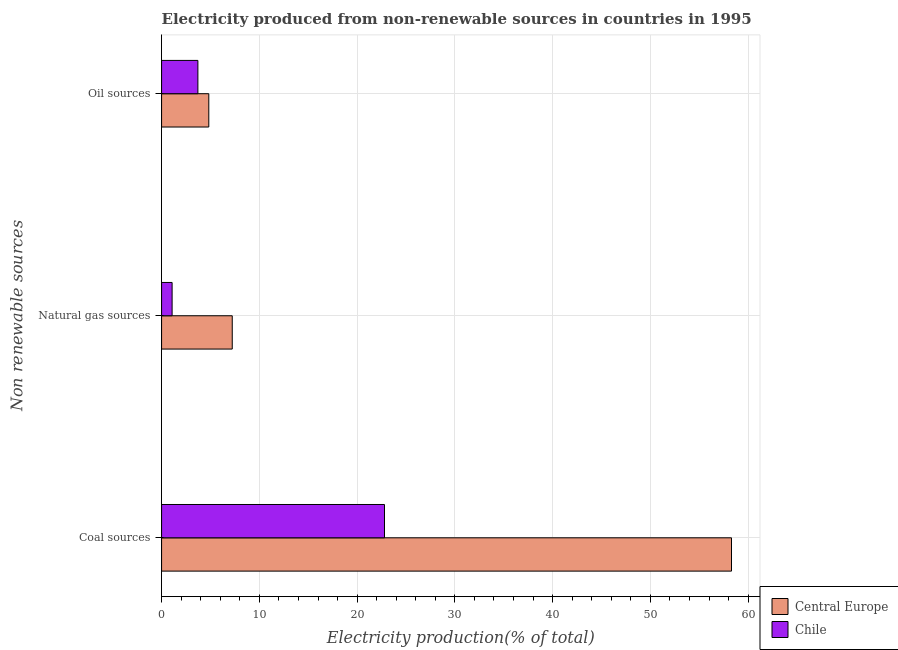Are the number of bars per tick equal to the number of legend labels?
Keep it short and to the point. Yes. How many bars are there on the 2nd tick from the top?
Give a very brief answer. 2. What is the label of the 3rd group of bars from the top?
Provide a short and direct response. Coal sources. What is the percentage of electricity produced by oil sources in Chile?
Make the answer very short. 3.71. Across all countries, what is the maximum percentage of electricity produced by oil sources?
Your answer should be compact. 4.83. Across all countries, what is the minimum percentage of electricity produced by oil sources?
Ensure brevity in your answer.  3.71. In which country was the percentage of electricity produced by oil sources maximum?
Provide a short and direct response. Central Europe. In which country was the percentage of electricity produced by oil sources minimum?
Offer a terse response. Chile. What is the total percentage of electricity produced by oil sources in the graph?
Give a very brief answer. 8.55. What is the difference between the percentage of electricity produced by coal in Chile and that in Central Europe?
Your answer should be very brief. -35.49. What is the difference between the percentage of electricity produced by natural gas in Chile and the percentage of electricity produced by coal in Central Europe?
Your answer should be very brief. -57.22. What is the average percentage of electricity produced by oil sources per country?
Offer a very short reply. 4.27. What is the difference between the percentage of electricity produced by oil sources and percentage of electricity produced by natural gas in Chile?
Give a very brief answer. 2.64. In how many countries, is the percentage of electricity produced by coal greater than 40 %?
Provide a succinct answer. 1. What is the ratio of the percentage of electricity produced by coal in Central Europe to that in Chile?
Keep it short and to the point. 2.56. Is the percentage of electricity produced by oil sources in Central Europe less than that in Chile?
Provide a short and direct response. No. Is the difference between the percentage of electricity produced by coal in Chile and Central Europe greater than the difference between the percentage of electricity produced by oil sources in Chile and Central Europe?
Offer a terse response. No. What is the difference between the highest and the second highest percentage of electricity produced by oil sources?
Your answer should be compact. 1.12. What is the difference between the highest and the lowest percentage of electricity produced by coal?
Your answer should be compact. 35.49. In how many countries, is the percentage of electricity produced by natural gas greater than the average percentage of electricity produced by natural gas taken over all countries?
Provide a short and direct response. 1. What does the 2nd bar from the top in Coal sources represents?
Make the answer very short. Central Europe. Is it the case that in every country, the sum of the percentage of electricity produced by coal and percentage of electricity produced by natural gas is greater than the percentage of electricity produced by oil sources?
Give a very brief answer. Yes. How many bars are there?
Give a very brief answer. 6. Are all the bars in the graph horizontal?
Your response must be concise. Yes. Are the values on the major ticks of X-axis written in scientific E-notation?
Offer a very short reply. No. Does the graph contain grids?
Keep it short and to the point. Yes. Where does the legend appear in the graph?
Provide a succinct answer. Bottom right. How many legend labels are there?
Keep it short and to the point. 2. What is the title of the graph?
Keep it short and to the point. Electricity produced from non-renewable sources in countries in 1995. What is the label or title of the X-axis?
Provide a short and direct response. Electricity production(% of total). What is the label or title of the Y-axis?
Your response must be concise. Non renewable sources. What is the Electricity production(% of total) in Central Europe in Coal sources?
Offer a very short reply. 58.3. What is the Electricity production(% of total) of Chile in Coal sources?
Your answer should be compact. 22.8. What is the Electricity production(% of total) in Central Europe in Natural gas sources?
Offer a very short reply. 7.23. What is the Electricity production(% of total) in Chile in Natural gas sources?
Make the answer very short. 1.08. What is the Electricity production(% of total) in Central Europe in Oil sources?
Provide a short and direct response. 4.83. What is the Electricity production(% of total) in Chile in Oil sources?
Your answer should be compact. 3.71. Across all Non renewable sources, what is the maximum Electricity production(% of total) in Central Europe?
Your answer should be very brief. 58.3. Across all Non renewable sources, what is the maximum Electricity production(% of total) in Chile?
Ensure brevity in your answer.  22.8. Across all Non renewable sources, what is the minimum Electricity production(% of total) in Central Europe?
Provide a succinct answer. 4.83. Across all Non renewable sources, what is the minimum Electricity production(% of total) in Chile?
Keep it short and to the point. 1.08. What is the total Electricity production(% of total) of Central Europe in the graph?
Your response must be concise. 70.36. What is the total Electricity production(% of total) of Chile in the graph?
Your answer should be compact. 27.59. What is the difference between the Electricity production(% of total) of Central Europe in Coal sources and that in Natural gas sources?
Your answer should be very brief. 51.07. What is the difference between the Electricity production(% of total) in Chile in Coal sources and that in Natural gas sources?
Your answer should be compact. 21.73. What is the difference between the Electricity production(% of total) of Central Europe in Coal sources and that in Oil sources?
Provide a succinct answer. 53.47. What is the difference between the Electricity production(% of total) in Chile in Coal sources and that in Oil sources?
Your answer should be compact. 19.09. What is the difference between the Electricity production(% of total) of Central Europe in Natural gas sources and that in Oil sources?
Provide a succinct answer. 2.4. What is the difference between the Electricity production(% of total) in Chile in Natural gas sources and that in Oil sources?
Your answer should be compact. -2.64. What is the difference between the Electricity production(% of total) in Central Europe in Coal sources and the Electricity production(% of total) in Chile in Natural gas sources?
Your response must be concise. 57.22. What is the difference between the Electricity production(% of total) of Central Europe in Coal sources and the Electricity production(% of total) of Chile in Oil sources?
Provide a short and direct response. 54.58. What is the difference between the Electricity production(% of total) of Central Europe in Natural gas sources and the Electricity production(% of total) of Chile in Oil sources?
Give a very brief answer. 3.51. What is the average Electricity production(% of total) in Central Europe per Non renewable sources?
Offer a terse response. 23.45. What is the average Electricity production(% of total) of Chile per Non renewable sources?
Your response must be concise. 9.2. What is the difference between the Electricity production(% of total) of Central Europe and Electricity production(% of total) of Chile in Coal sources?
Give a very brief answer. 35.49. What is the difference between the Electricity production(% of total) in Central Europe and Electricity production(% of total) in Chile in Natural gas sources?
Your answer should be very brief. 6.15. What is the difference between the Electricity production(% of total) of Central Europe and Electricity production(% of total) of Chile in Oil sources?
Provide a succinct answer. 1.12. What is the ratio of the Electricity production(% of total) of Central Europe in Coal sources to that in Natural gas sources?
Your answer should be compact. 8.06. What is the ratio of the Electricity production(% of total) in Chile in Coal sources to that in Natural gas sources?
Make the answer very short. 21.16. What is the ratio of the Electricity production(% of total) of Central Europe in Coal sources to that in Oil sources?
Give a very brief answer. 12.07. What is the ratio of the Electricity production(% of total) of Chile in Coal sources to that in Oil sources?
Make the answer very short. 6.14. What is the ratio of the Electricity production(% of total) in Central Europe in Natural gas sources to that in Oil sources?
Offer a terse response. 1.5. What is the ratio of the Electricity production(% of total) of Chile in Natural gas sources to that in Oil sources?
Your answer should be compact. 0.29. What is the difference between the highest and the second highest Electricity production(% of total) of Central Europe?
Ensure brevity in your answer.  51.07. What is the difference between the highest and the second highest Electricity production(% of total) of Chile?
Your response must be concise. 19.09. What is the difference between the highest and the lowest Electricity production(% of total) of Central Europe?
Provide a succinct answer. 53.47. What is the difference between the highest and the lowest Electricity production(% of total) of Chile?
Your answer should be compact. 21.73. 